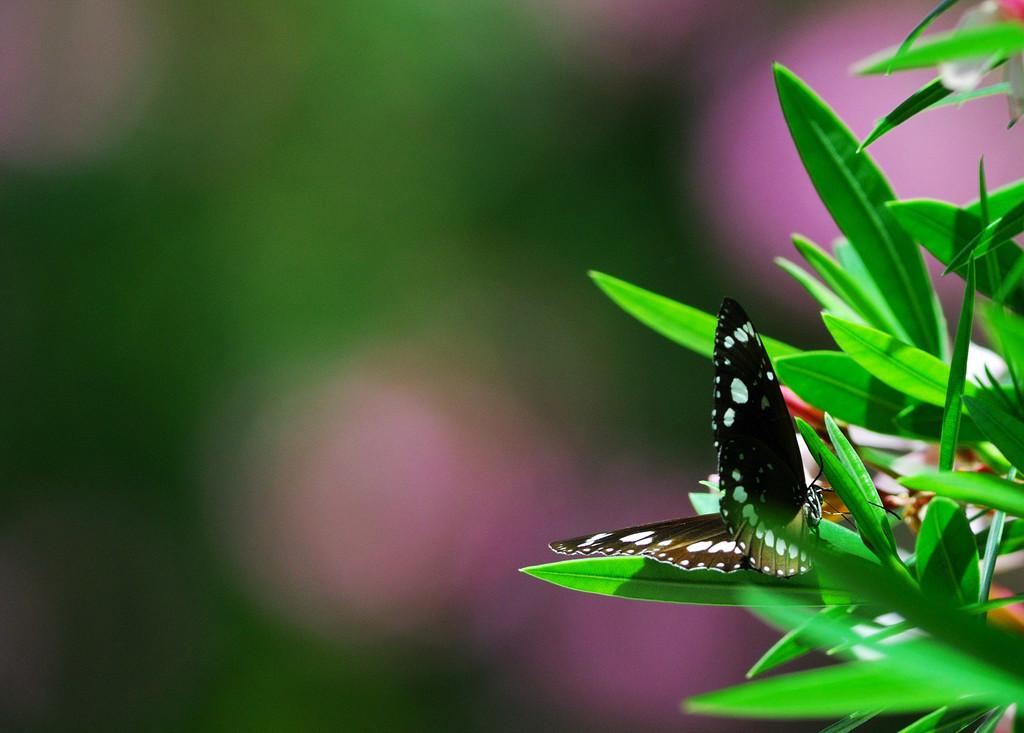What type of vegetation can be seen in the image? There are green leaves in the image. What animal is present in the image? There is a butterfly in the image. What colors are visible on the butterfly? The butterfly is brown and white in color. How is the butterfly positioned in the image? The butterfly appears blurred in the background. Can you tell me where the toad is hiding in the image? There is no toad present in the image. What type of pickle is being used as a prop in the image? There is no pickle present in the image. 